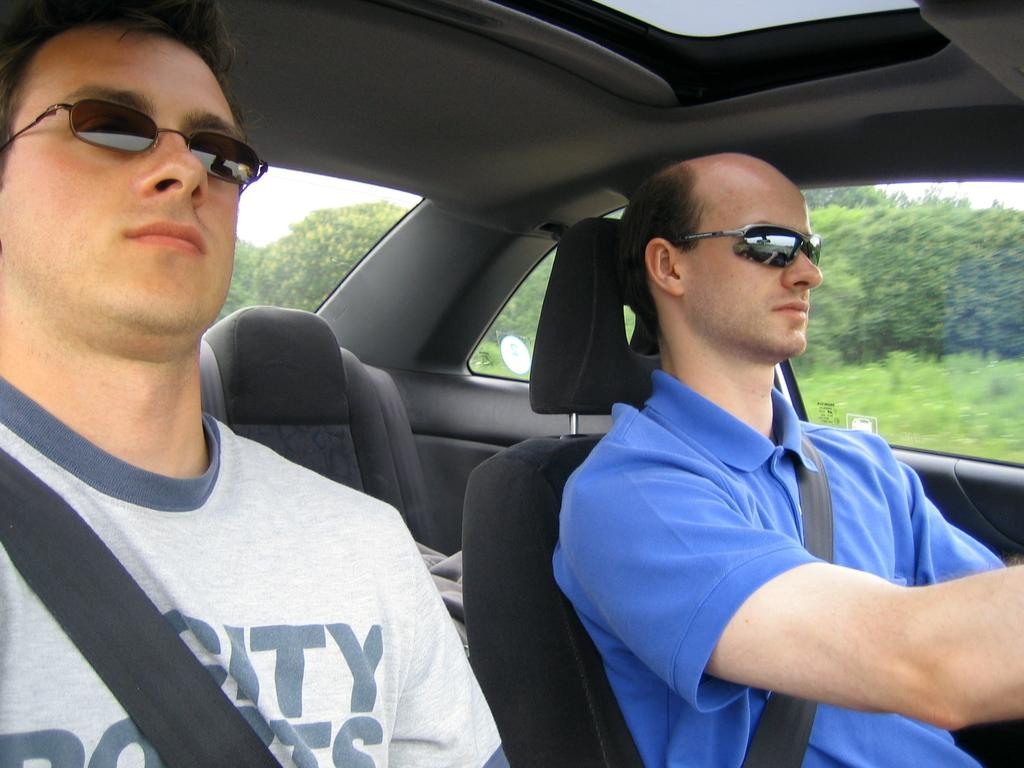What are the two persons in the image doing? The two persons are sitting in a car. What can be seen on the faces of the two persons? The two persons are wearing glasses. What is visible in the background of the image? There is a tree, plants, and the sky visible in the background of the image. What type of shoes can be seen on the persons in the image? There is no information about shoes in the image; only the persons sitting in the car and wearing glasses are mentioned. 